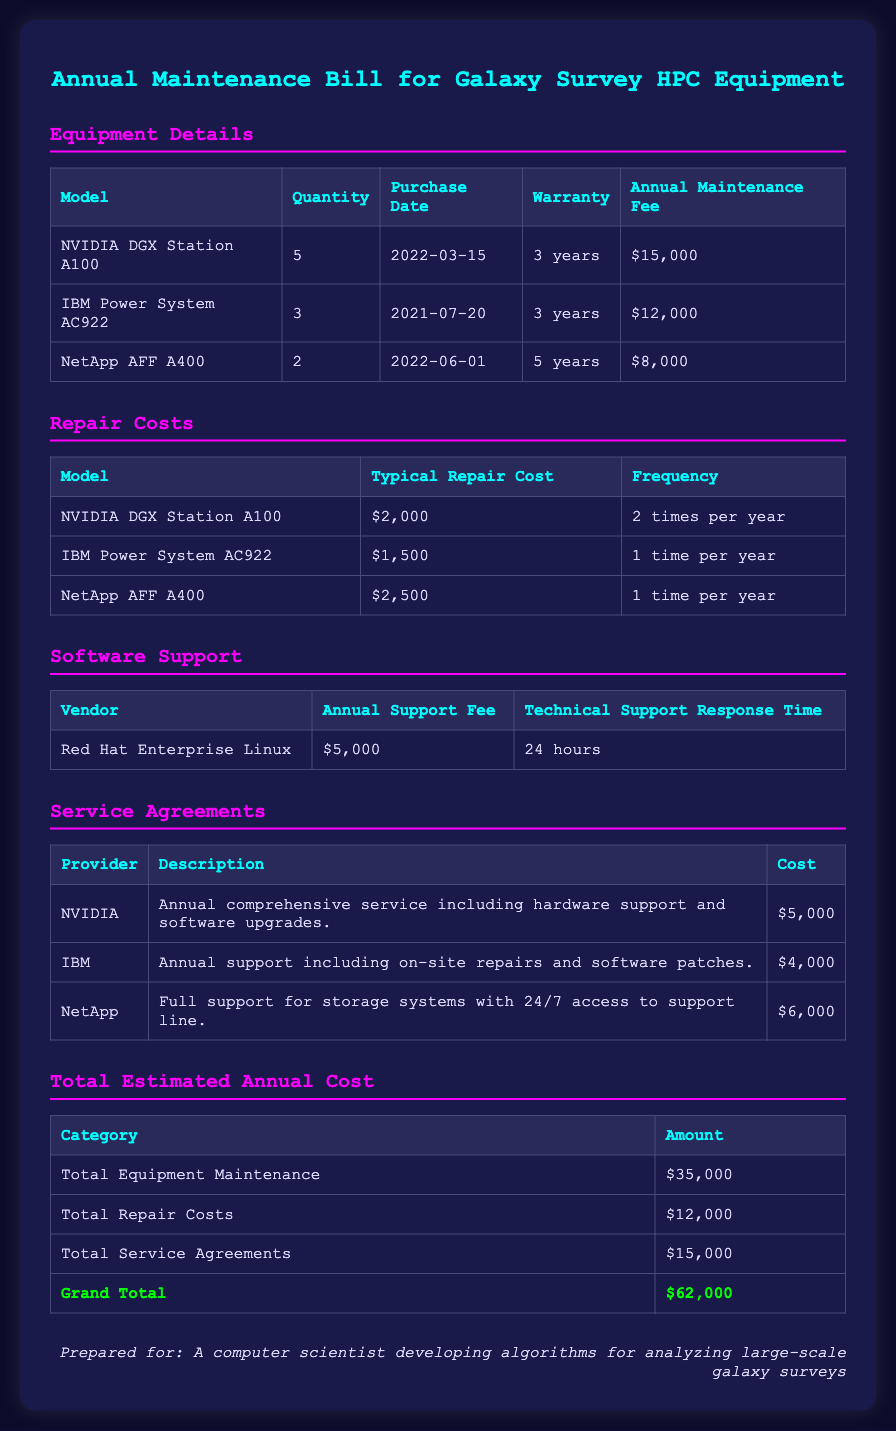What is the total annual maintenance fee for NVIDIA DGX Station A100? The annual maintenance fee for NVIDIA DGX Station A100 is $15,000.
Answer: $15,000 How many IBM Power System AC922 units are there? The document states there are 3 IBM Power System AC922 units listed.
Answer: 3 What is the typical repair cost for NetApp AFF A400? According to the document, the typical repair cost for NetApp AFF A400 is $2,500.
Answer: $2,500 What is the technical support response time for Red Hat Enterprise Linux? Red Hat Enterprise Linux provides a technical support response time of 24 hours.
Answer: 24 hours What is the grand total of all estimated annual costs? The grand total of all estimated annual costs is calculated to be $62,000.
Answer: $62,000 Which vendor has the highest annual support fee? The vendor with the highest annual support fee is Red Hat Enterprise Linux at $5,000.
Answer: Red Hat Enterprise Linux How many times per year is the NVIDIA DGX Station A100 expected to be repaired? The NVIDIA DGX Station A100 is expected to be repaired 2 times per year.
Answer: 2 times per year What is included in NVIDIA's service agreement? The service agreement includes annual comprehensive service including hardware support and software upgrades.
Answer: Comprehensive service including hardware support and software upgrades What is the total equipment maintenance cost for all models? The total equipment maintenance cost for all models is $35,000.
Answer: $35,000 